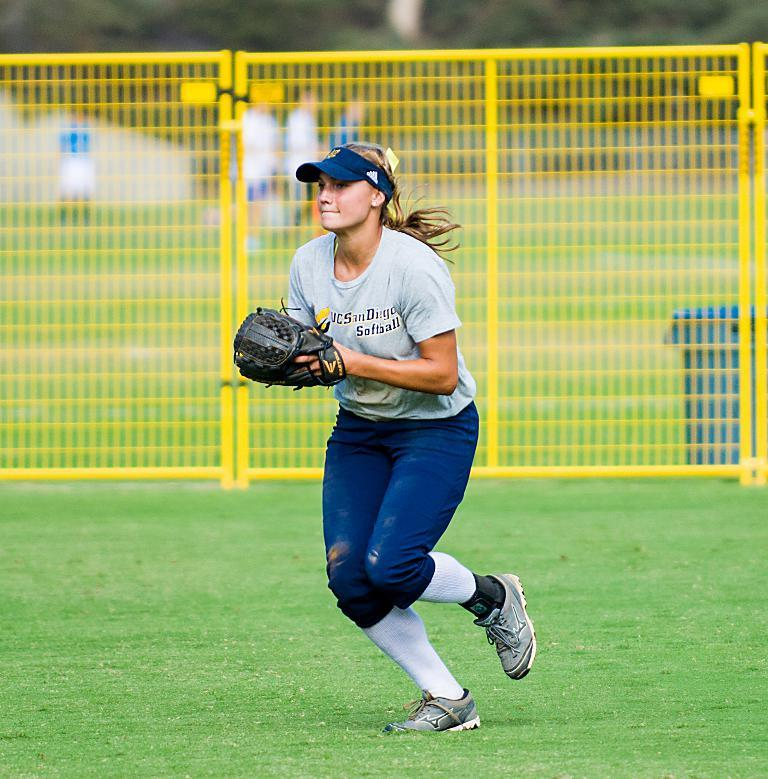Who is the main subject in the image? There is a woman in the image. What is the woman standing on? The woman is standing on a green ground. What is the woman wearing on her hands? The woman is wearing gloves. What can be seen in the background of the image? There is a yellow fence, people, and trees in the background of the image. What letters are used to form the caption for the image? There is no caption present in the image, so no letters can be identified. What type of agreement is being signed by the woman in the image? There is no indication of a signing or agreement in the image; the woman is simply standing on a green ground. 